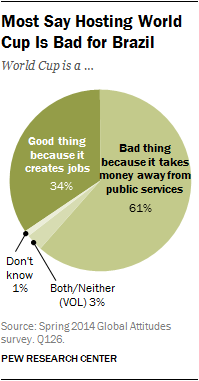List a handful of essential elements in this visual. The difference in opinions between those who think it is bad and those who think it is good is approximately 27%. According to a survey, 61% of people believe that it is a bad thing. 